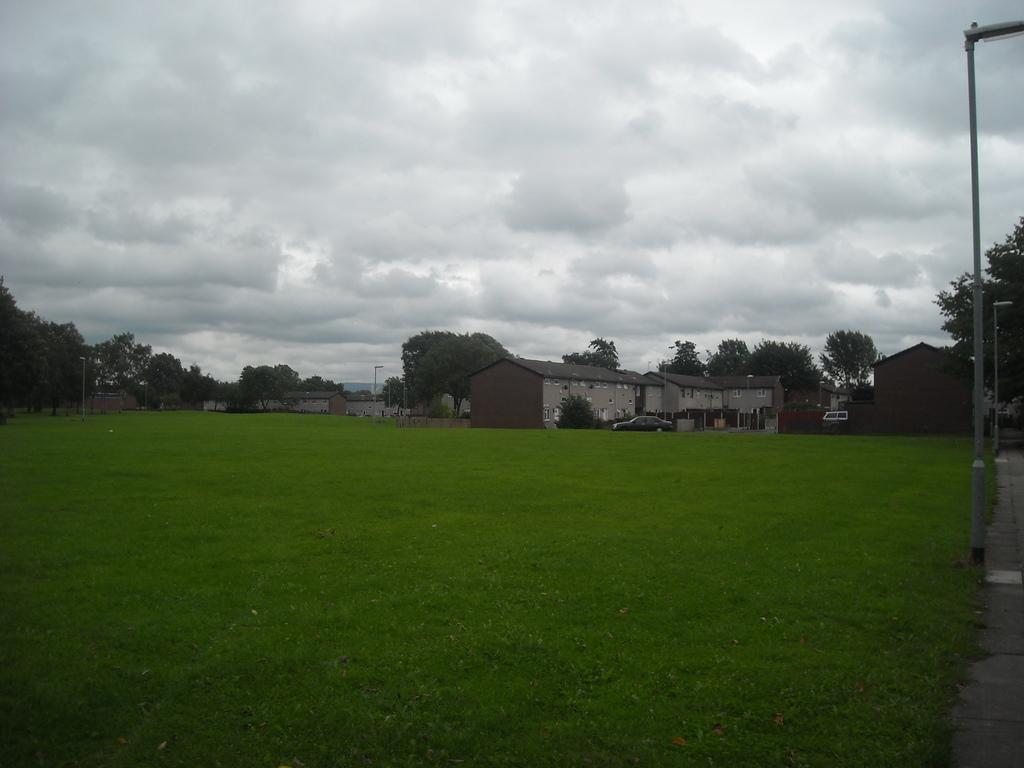What type of vegetation is in the center of the image? There is grass in the center of the image. What structures can be seen in the background of the image? There are houses in the background of the image. What other natural elements are present in the background of the image? There are trees in the background of the image. What is visible in the sky at the top of the image? There are clouds visible at the top of the image. Where is the river located in the image? There is no river present in the image. What type of toys can be seen in the grass in the image? There are no toys visible in the grass in the image. 